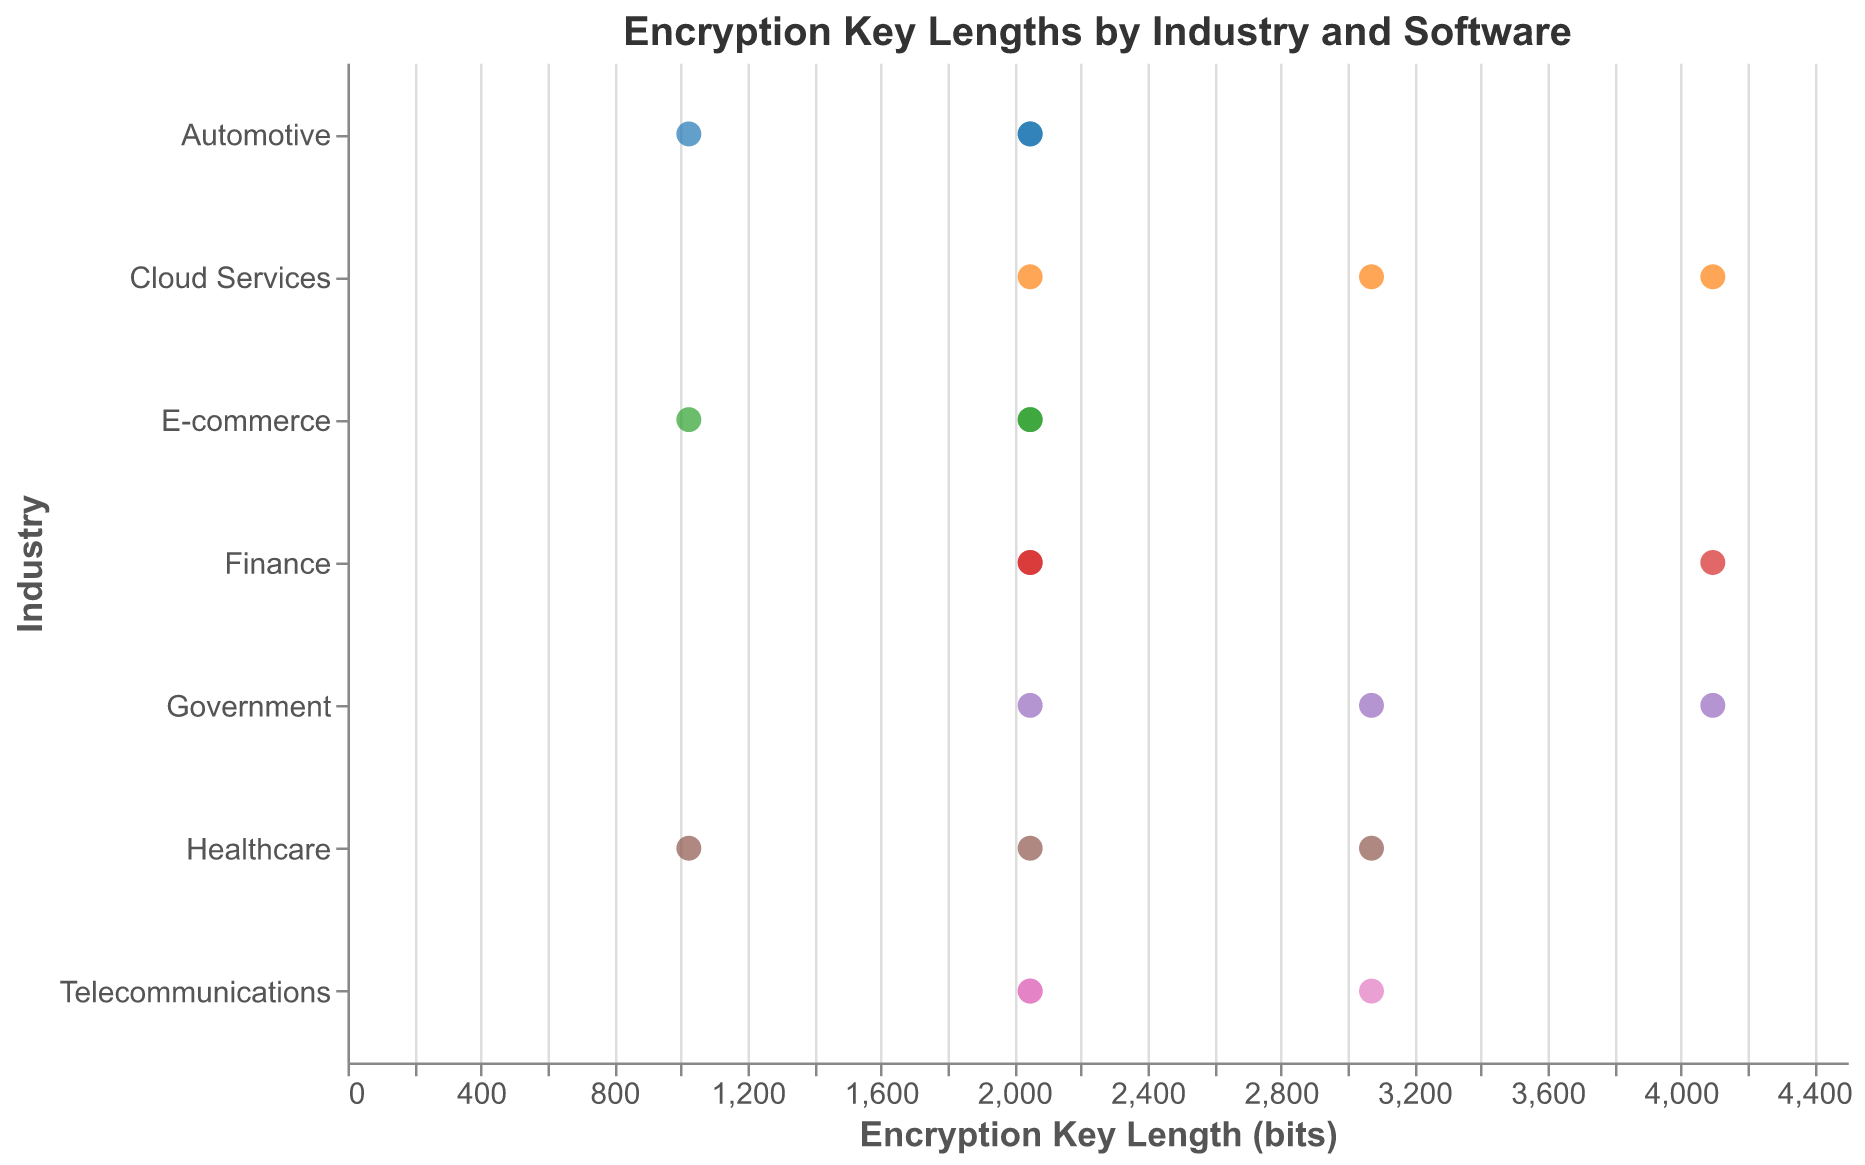What industry uses the longest encryption key length? The longest encryption key length shown in the strip plot is 4096 bits. In the plot, this key length appears in both the Finance and Government industries.
Answer: Finance, Government Which industries have the most software using a 2048-bit encryption key? Looking at the plot, count the number of points at 2048 bits for each industry. Finance, E-commerce, Telecommunications, Cloud Services, and Automotive have the highest counts with 2, 2, 2, 1, and 2 data points, respectively. Finance has the most with 3.
Answer: Finance What's the range of encryption key lengths used in the Healthcare industry? In the plot, the Healthcare industry shows key lengths of 1024, 2048, and 3072 bits. The range is the difference between the highest (3072) and the lowest (1024) value.
Answer: 2048 How many software products use a 1024-bit encryption key? Identify the points corresponding to a 1024-bit encryption key across all industries in the plot. They appear in Healthcare, E-commerce, and Automotive with one software product each, totaling three.
Answer: 3 What is the average encryption key length used in the Cloud Services industry? Looking at the plot, the Cloud Services products have key lengths of 4096, 2048, and 3072 bits. Calculate the average: (4096 + 2048 + 3072) / 3 = 3072.
Answer: 3072 Is there any industry that uses only one specific encryption key length? Examine all points within each industry. Industries such as Finance use 2048 and 4096 bits, not just one length. However, some industries, like Automotive, use only 2048 bits (except for one instance). There is no industry with only one key length without exception.
Answer: No What is the most common encryption key length across all industries? Count the occurrences of each key length in the plot. The most frequent one is 2048 bits, as it appears the most across different industries.
Answer: 2048 Which software product from Finance uses the longest encryption key? Examine the key lengths for products in the Finance industry. The longest one is 4096 bits, which is used by Stripe.
Answer: Stripe Comparing Healthcare and Telecommunications industries, which has a wider range of encryption key lengths? Healthcare has key lengths of 1024, 2048, and 3072, giving a range of 2048 (3072 - 1024). Telecommunications has 2048 and 3072, a range of 1024 (3072 - 2048). Therefore, Healthcare has a wider range.
Answer: Healthcare Which industry shows the highest key length variability? Variability can be interpreted as the range or spread. Comparing ranges: Healthcare (2048), Government (2048), Finance (2048), Telecommunications (1024), E-commerce (1024), Cloud Services (2048), Automotive (1024). Multiple industries tie, including Healthcare, Government, Finance, and Cloud Services, with a range of 2048.
Answer: Healthcare, Government, Finance, Cloud Services 